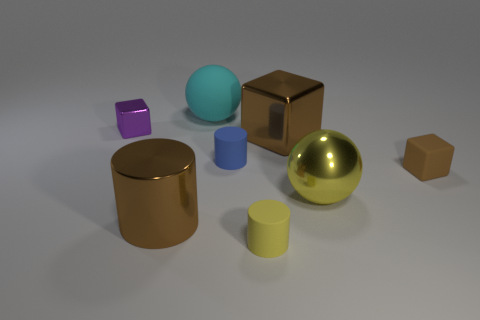Subtract all brown cubes. How many cubes are left? 1 Add 2 metal cylinders. How many objects exist? 10 Subtract all yellow cylinders. How many cylinders are left? 2 Subtract 1 brown blocks. How many objects are left? 7 Subtract all cylinders. How many objects are left? 5 Subtract 1 cubes. How many cubes are left? 2 Subtract all yellow cubes. Subtract all blue cylinders. How many cubes are left? 3 Subtract all gray cylinders. How many brown blocks are left? 2 Subtract all brown blocks. Subtract all large brown spheres. How many objects are left? 6 Add 3 small shiny cubes. How many small shiny cubes are left? 4 